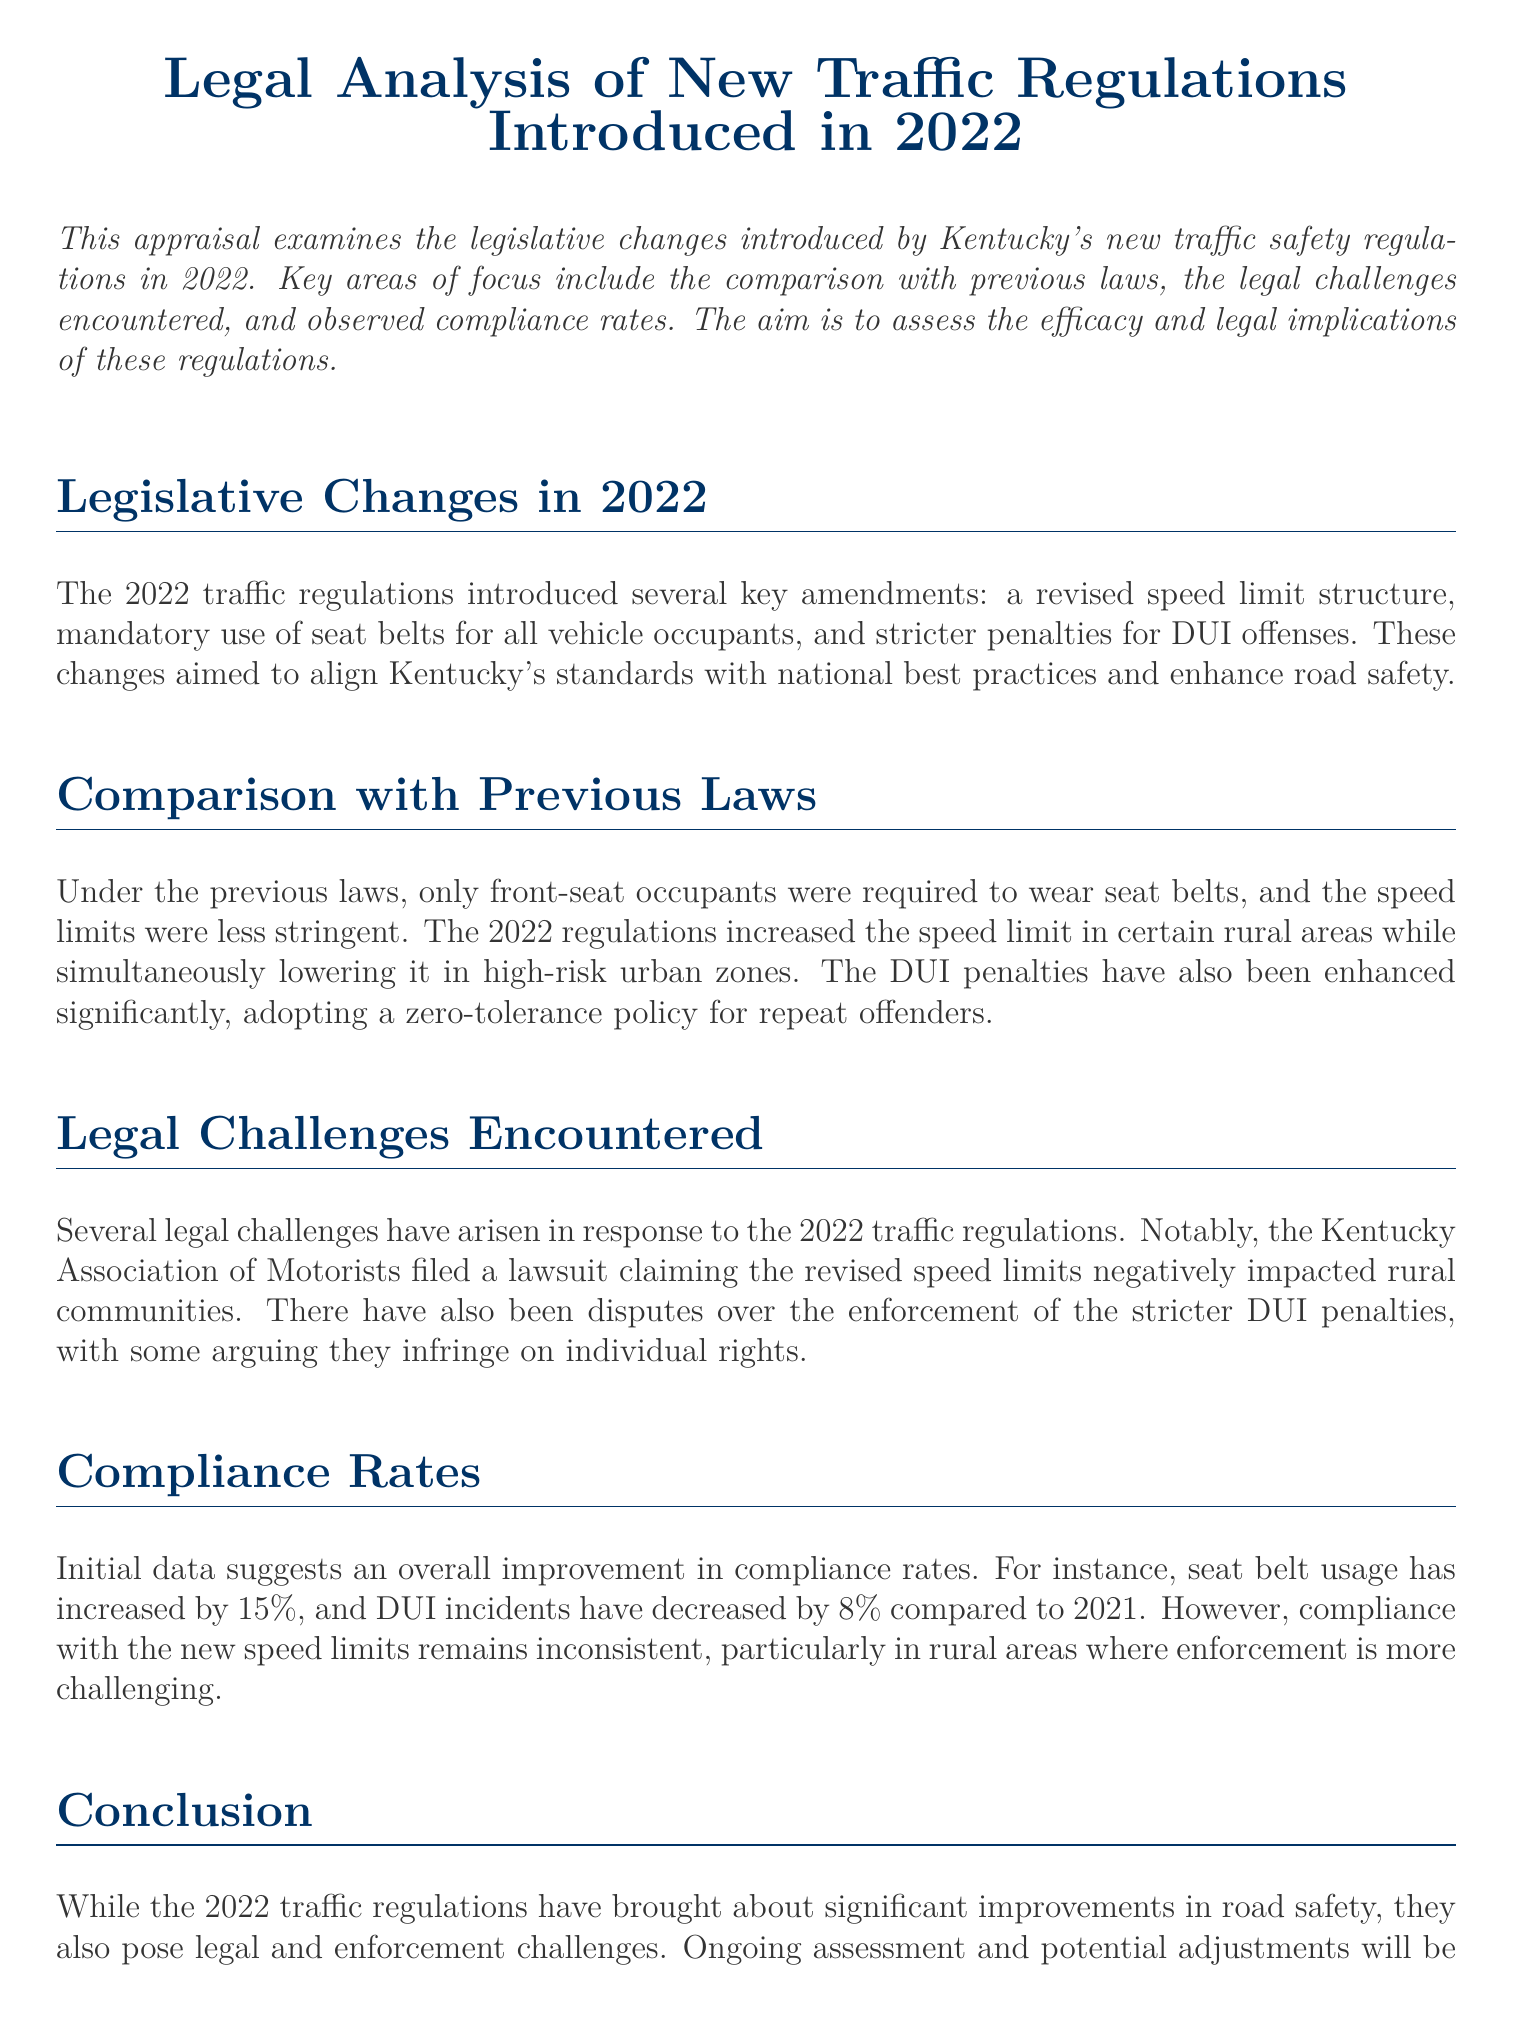What are the key amendments introduced in 2022? The document states that the key amendments include a revised speed limit structure, mandatory use of seat belts for all vehicle occupants, and stricter penalties for DUI offenses.
Answer: Revised speed limit structure, mandatory seat belts, stricter DUI penalties How much has seat belt usage increased? The document mentions that seat belt usage has increased by 15 percent compared to previous years.
Answer: 15 percent Which organization filed a lawsuit against the new speed limits? The document states that the Kentucky Association of Motorists filed a lawsuit claiming the revised speed limits negatively impacted rural communities.
Answer: Kentucky Association of Motorists What has happened to DUI incidents compared to 2021? The document indicates that DUI incidents have decreased by 8 percent compared to 2021.
Answer: Decreased by 8 percent Which policy regarding DUI offenses was adopted in 2022? The document explains that a zero-tolerance policy for repeat offenders was adopted for DUI offenses in 2022.
Answer: Zero-tolerance policy for repeat offenders How did the new speed limit regulations change in rural areas? The law states that the speed limits in certain rural areas were increased under the new regulations.
Answer: Increased What does the document suggest is essential for the future of traffic regulations? The conclusion of the document indicates that ongoing assessment and potential adjustments are essential for ensuring the regulations meet their goals effectively.
Answer: Ongoing assessment and potential adjustments What overall effect have the 2022 regulations had on road safety? The document concludes that the 2022 traffic regulations have brought about significant improvements in road safety.
Answer: Significant improvements in road safety 